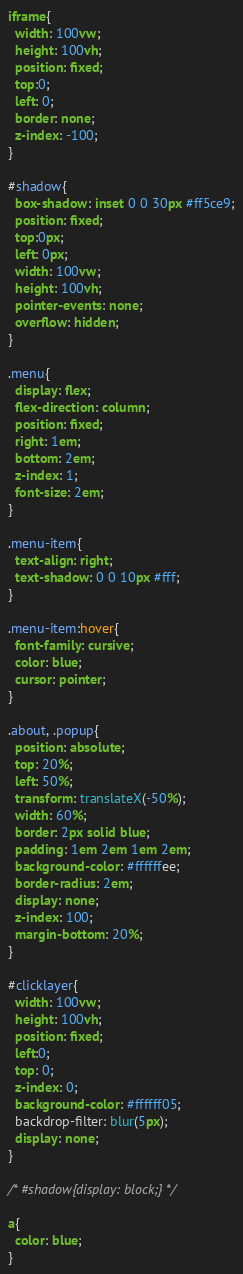<code> <loc_0><loc_0><loc_500><loc_500><_CSS_>iframe{
  width: 100vw;
  height: 100vh;
  position: fixed;
  top:0;
  left: 0;
  border: none;
  z-index: -100;
}

#shadow{
  box-shadow: inset 0 0 30px #ff5ce9;
  position: fixed;
  top:0px;
  left: 0px;
  width: 100vw;
  height: 100vh;
  pointer-events: none;
  overflow: hidden;
}

.menu{
  display: flex;
  flex-direction: column;
  position: fixed;
  right: 1em;
  bottom: 2em;
  z-index: 1;
  font-size: 2em;
}

.menu-item{
  text-align: right;
  text-shadow: 0 0 10px #fff;
}

.menu-item:hover{
  font-family: cursive;
  color: blue;
  cursor: pointer;
}

.about, .popup{
  position: absolute;
  top: 20%;
  left: 50%;
  transform: translateX(-50%);
  width: 60%;
  border: 2px solid blue;
  padding: 1em 2em 1em 2em;
  background-color: #ffffffee;
  border-radius: 2em;
  display: none;
  z-index: 100;
  margin-bottom: 20%;
}

#clicklayer{
  width: 100vw;
  height: 100vh;
  position: fixed;
  left:0;
  top: 0;
  z-index: 0;
  background-color: #ffffff05;
  backdrop-filter: blur(5px);
  display: none;
}

/* #shadow{display: block;} */

a{
  color: blue;
}
</code> 